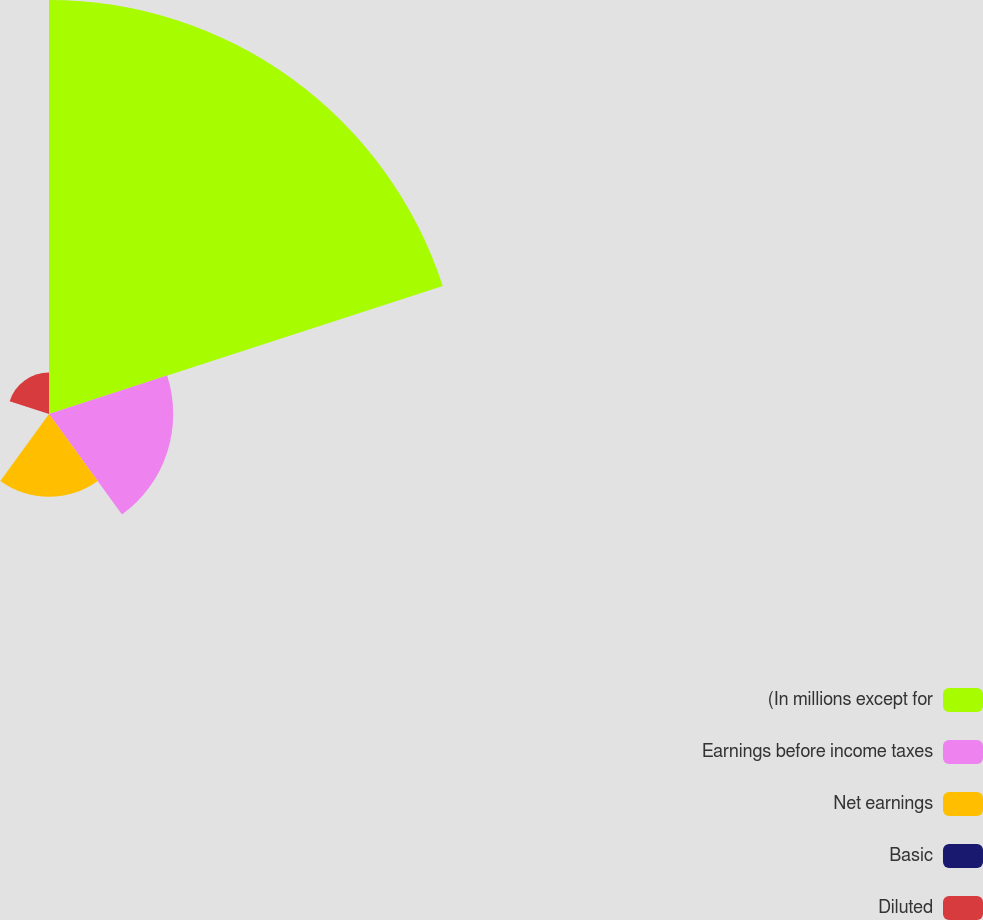Convert chart to OTSL. <chart><loc_0><loc_0><loc_500><loc_500><pie_chart><fcel>(In millions except for<fcel>Earnings before income taxes<fcel>Net earnings<fcel>Basic<fcel>Diluted<nl><fcel>62.5%<fcel>18.75%<fcel>12.5%<fcel>0.0%<fcel>6.25%<nl></chart> 